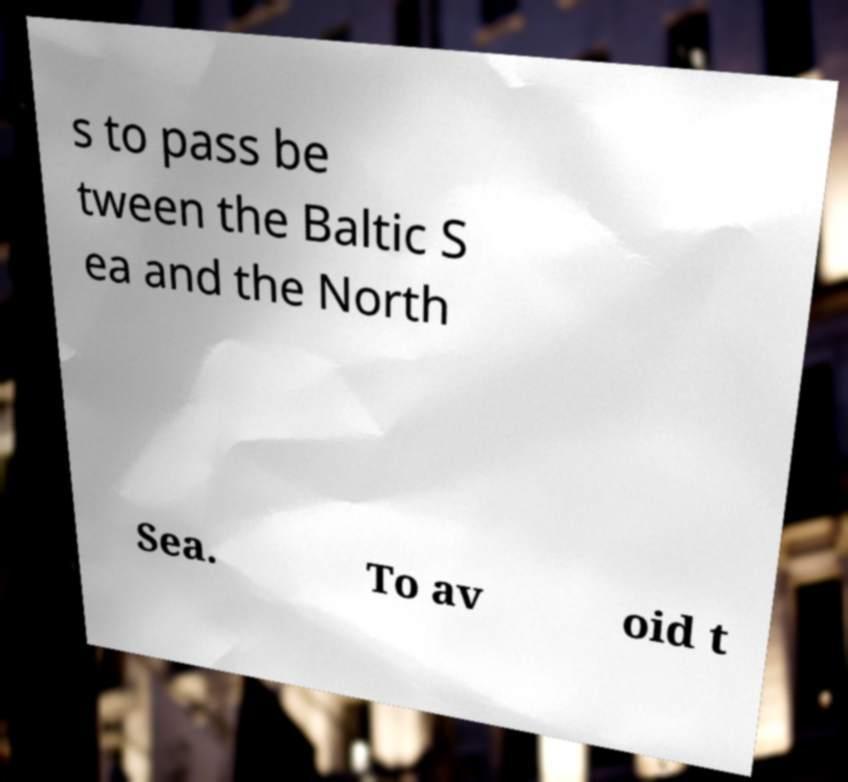There's text embedded in this image that I need extracted. Can you transcribe it verbatim? s to pass be tween the Baltic S ea and the North Sea. To av oid t 